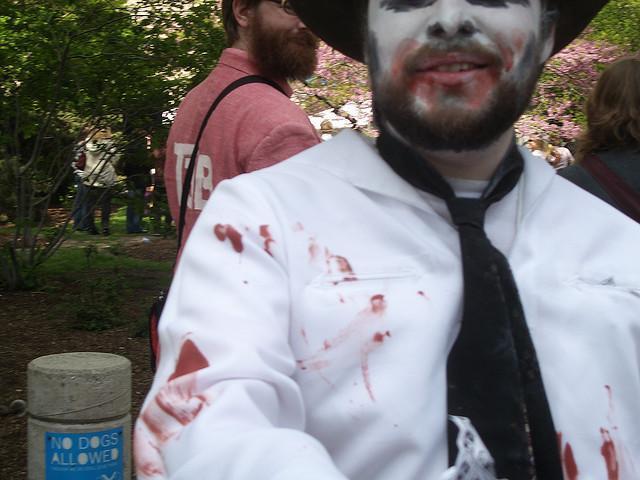How many people are in the photo?
Give a very brief answer. 5. How many benches are visible?
Give a very brief answer. 0. 